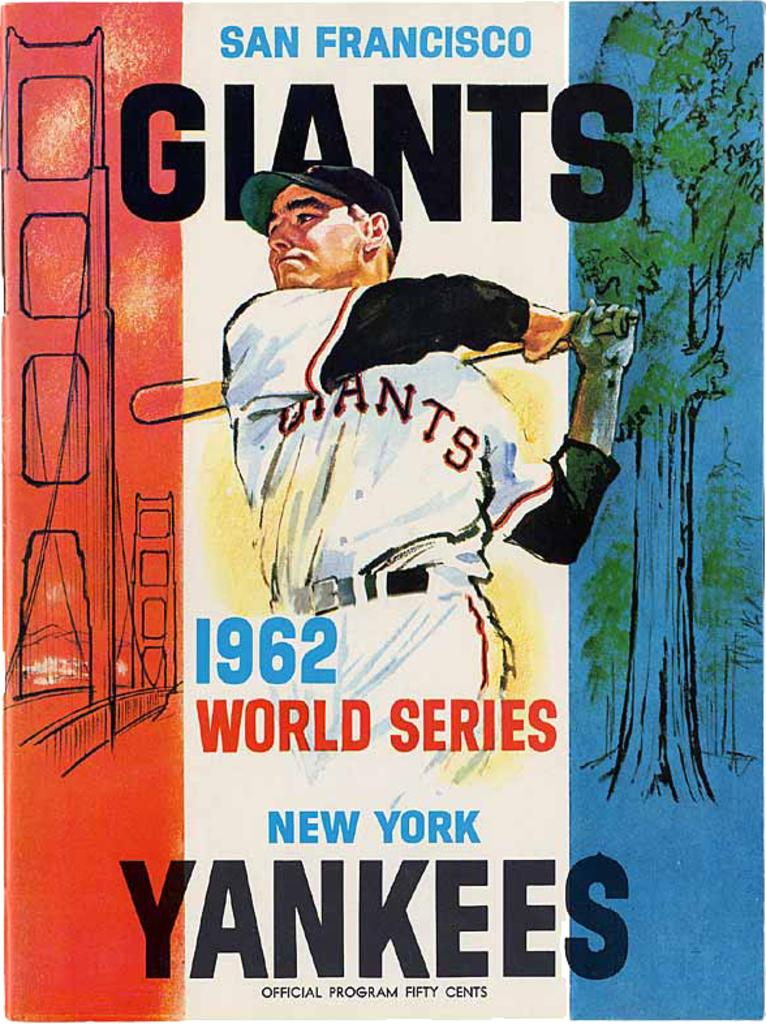<image>
Relay a brief, clear account of the picture shown. Poster for the World Series which takes place in 1962. 